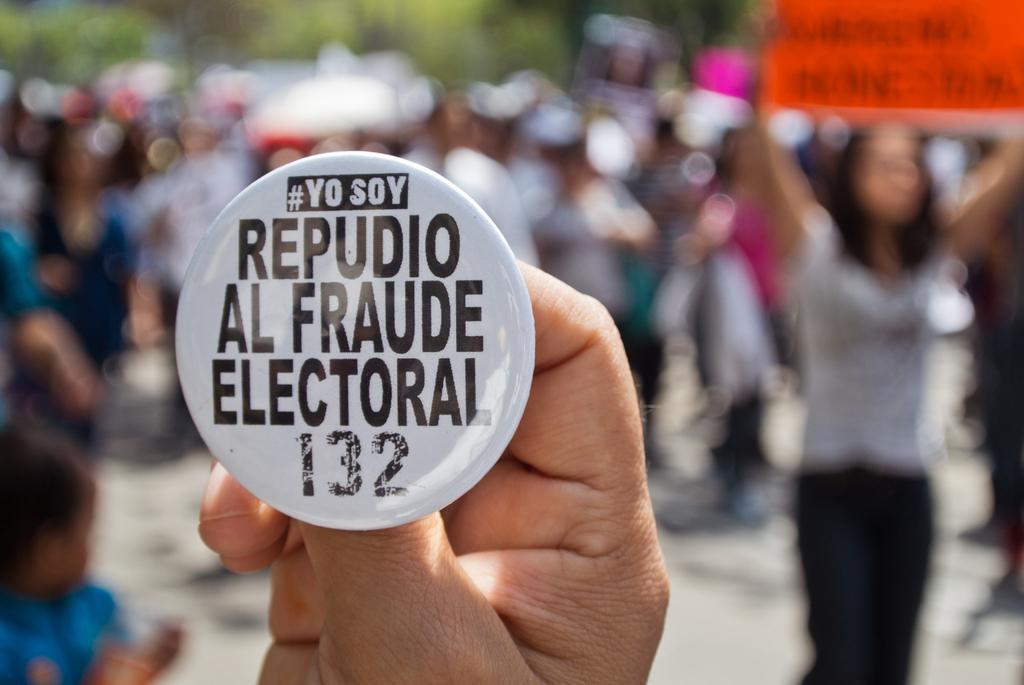What is the color of the badge in the image? The badge in the image is white. What is written on the badge? There is text on the badge. Can you describe the people in the background of the image? The background of the image is blurred, so it is difficult to describe the people in detail. What is the overall appearance of the background in the image? The background is blurred. What type of substance does the ghost in the image use to communicate? There is no ghost present in the image, so it is not possible to answer that question. 